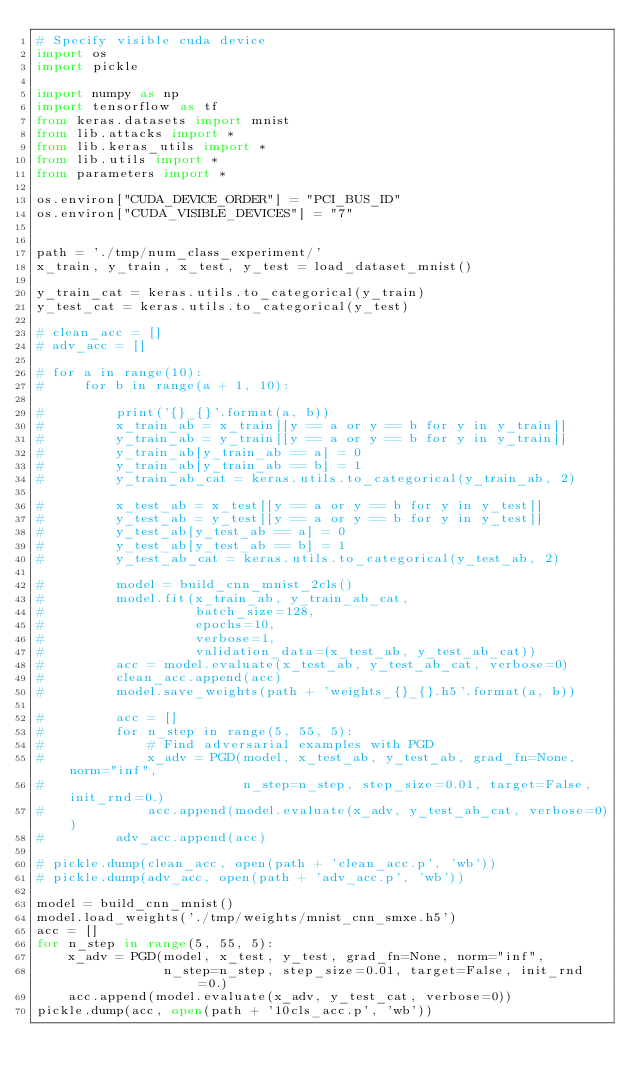Convert code to text. <code><loc_0><loc_0><loc_500><loc_500><_Python_># Specify visible cuda device
import os
import pickle

import numpy as np
import tensorflow as tf
from keras.datasets import mnist
from lib.attacks import *
from lib.keras_utils import *
from lib.utils import *
from parameters import *

os.environ["CUDA_DEVICE_ORDER"] = "PCI_BUS_ID"
os.environ["CUDA_VISIBLE_DEVICES"] = "7"


path = './tmp/num_class_experiment/'
x_train, y_train, x_test, y_test = load_dataset_mnist()

y_train_cat = keras.utils.to_categorical(y_train)
y_test_cat = keras.utils.to_categorical(y_test)

# clean_acc = []
# adv_acc = []

# for a in range(10):
#     for b in range(a + 1, 10):

#         print('{}_{}'.format(a, b))
#         x_train_ab = x_train[[y == a or y == b for y in y_train]]
#         y_train_ab = y_train[[y == a or y == b for y in y_train]]
#         y_train_ab[y_train_ab == a] = 0
#         y_train_ab[y_train_ab == b] = 1
#         y_train_ab_cat = keras.utils.to_categorical(y_train_ab, 2)

#         x_test_ab = x_test[[y == a or y == b for y in y_test]]
#         y_test_ab = y_test[[y == a or y == b for y in y_test]]
#         y_test_ab[y_test_ab == a] = 0
#         y_test_ab[y_test_ab == b] = 1
#         y_test_ab_cat = keras.utils.to_categorical(y_test_ab, 2)

#         model = build_cnn_mnist_2cls()
#         model.fit(x_train_ab, y_train_ab_cat,
#                   batch_size=128,
#                   epochs=10,
#                   verbose=1,
#                   validation_data=(x_test_ab, y_test_ab_cat))
#         acc = model.evaluate(x_test_ab, y_test_ab_cat, verbose=0)
#         clean_acc.append(acc)
#         model.save_weights(path + 'weights_{}_{}.h5'.format(a, b))

#         acc = []
#         for n_step in range(5, 55, 5):
#             # Find adversarial examples with PGD
#             x_adv = PGD(model, x_test_ab, y_test_ab, grad_fn=None, norm="inf",
#                         n_step=n_step, step_size=0.01, target=False, init_rnd=0.)
#             acc.append(model.evaluate(x_adv, y_test_ab_cat, verbose=0))
#         adv_acc.append(acc)

# pickle.dump(clean_acc, open(path + 'clean_acc.p', 'wb'))
# pickle.dump(adv_acc, open(path + 'adv_acc.p', 'wb'))

model = build_cnn_mnist()
model.load_weights('./tmp/weights/mnist_cnn_smxe.h5')
acc = []
for n_step in range(5, 55, 5):
    x_adv = PGD(model, x_test, y_test, grad_fn=None, norm="inf",
                n_step=n_step, step_size=0.01, target=False, init_rnd=0.)
    acc.append(model.evaluate(x_adv, y_test_cat, verbose=0))
pickle.dump(acc, open(path + '10cls_acc.p', 'wb'))
</code> 